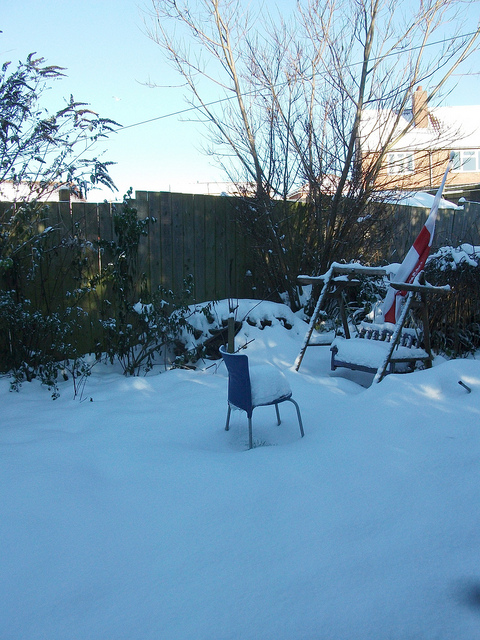<image>What is this person doing? It is unknown what this person is doing, as it appears there may not be a person present. What is this person doing? I don't know what this person is doing. It can be seen that the person is taking picture, playing in snow, sitting, standing outside or relaxing. 